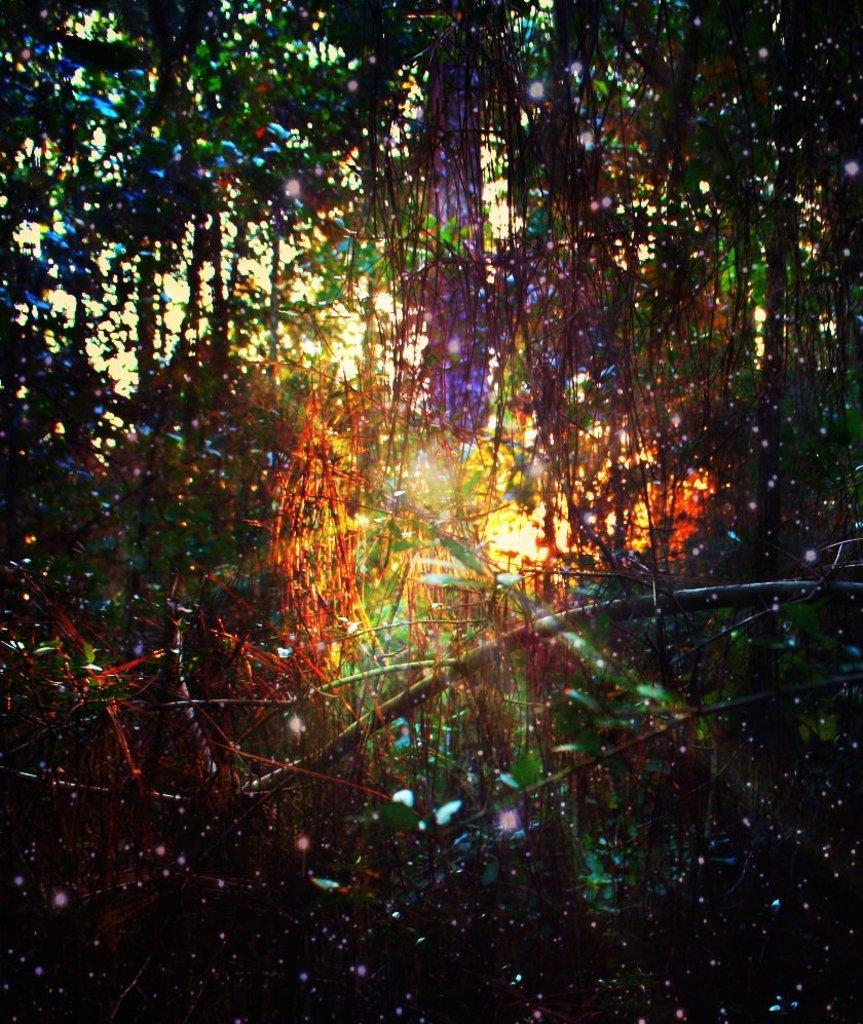Can you describe this image briefly? In this image there are trees, in between the trees there is sunlight. 